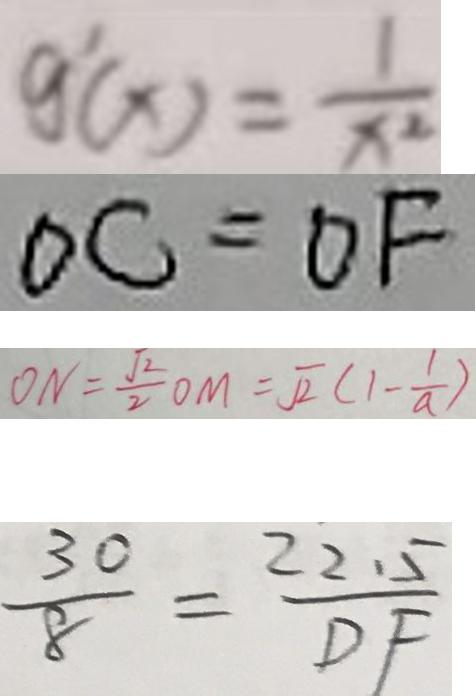<formula> <loc_0><loc_0><loc_500><loc_500>g ^ { \prime } ( x ) = \frac { 1 } { x ^ { 2 } } 
 O C = O F 
 O N = \frac { \sqrt { 2 } } { 2 } O M = \sqrt { 2 } ( 1 - \frac { 1 } { a } ) 
 \frac { 3 0 } { 8 } = \frac { 2 2 . 5 } { D F }</formula> 